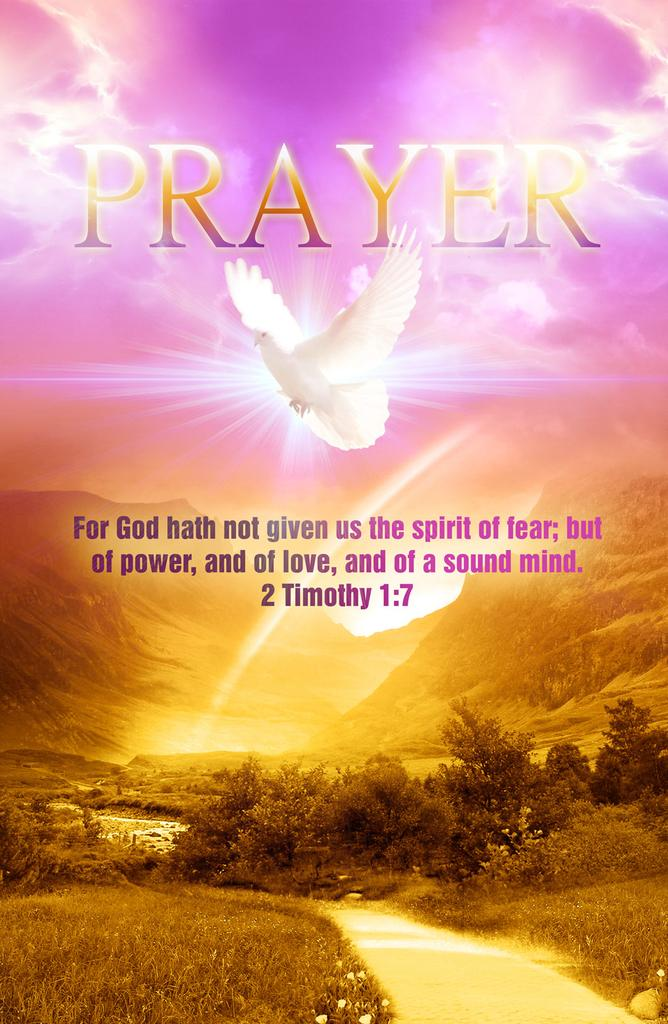<image>
Share a concise interpretation of the image provided. A dove flying on top of the mountain as a symbol that god hath not given us the spirit of fear but  of power. 